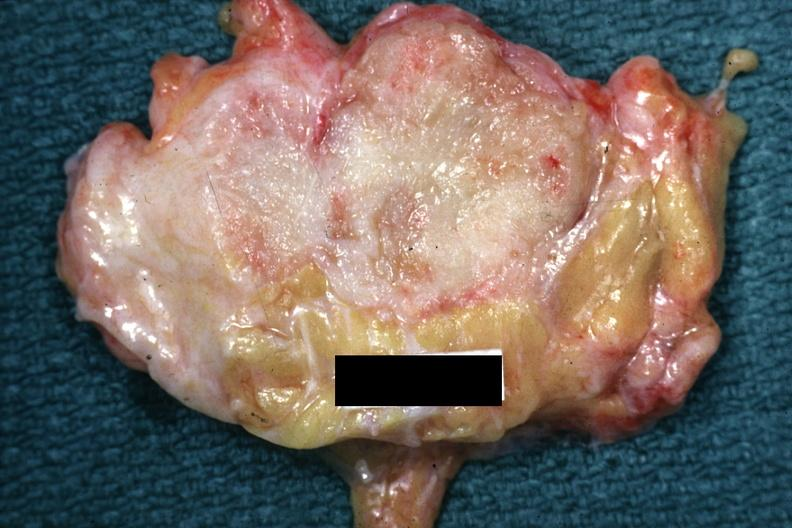how does lesion appear too for this?
Answer the question using a single word or phrase. Small 